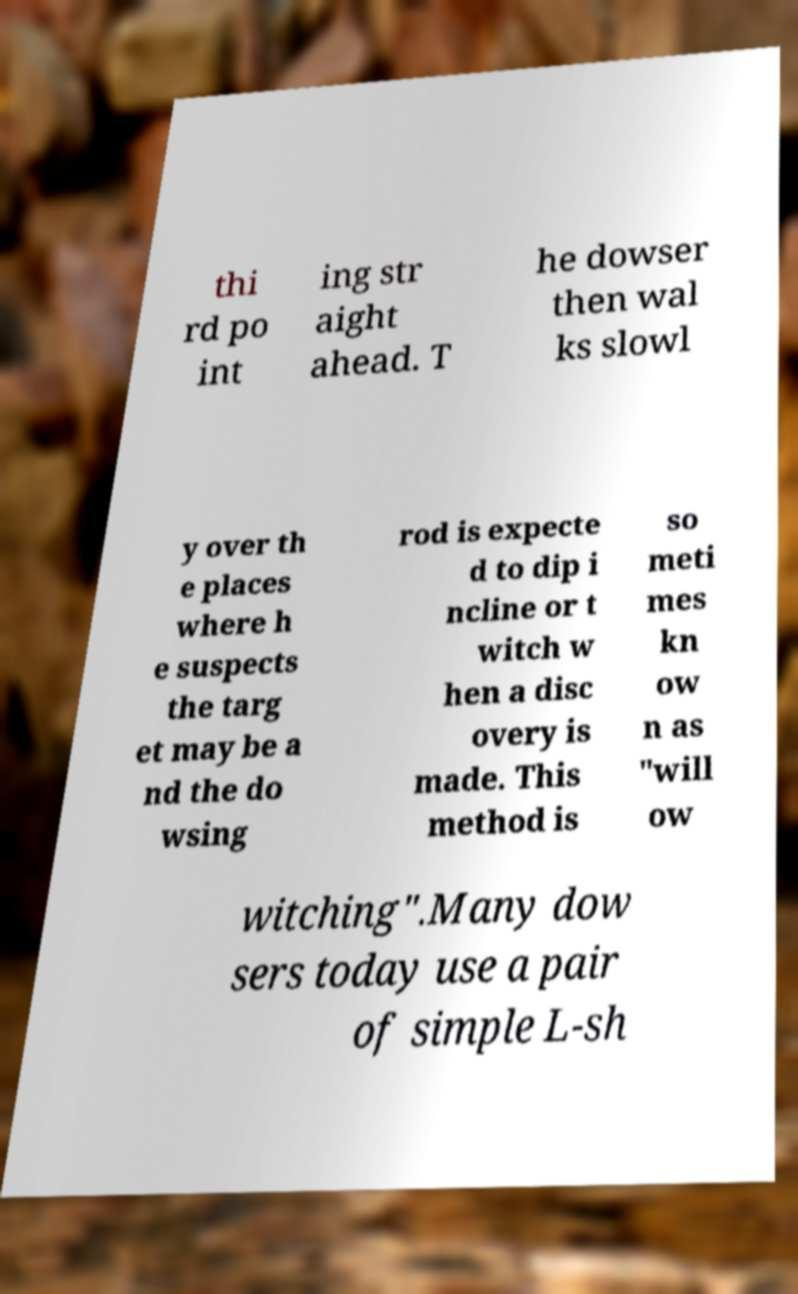What messages or text are displayed in this image? I need them in a readable, typed format. thi rd po int ing str aight ahead. T he dowser then wal ks slowl y over th e places where h e suspects the targ et may be a nd the do wsing rod is expecte d to dip i ncline or t witch w hen a disc overy is made. This method is so meti mes kn ow n as "will ow witching".Many dow sers today use a pair of simple L-sh 